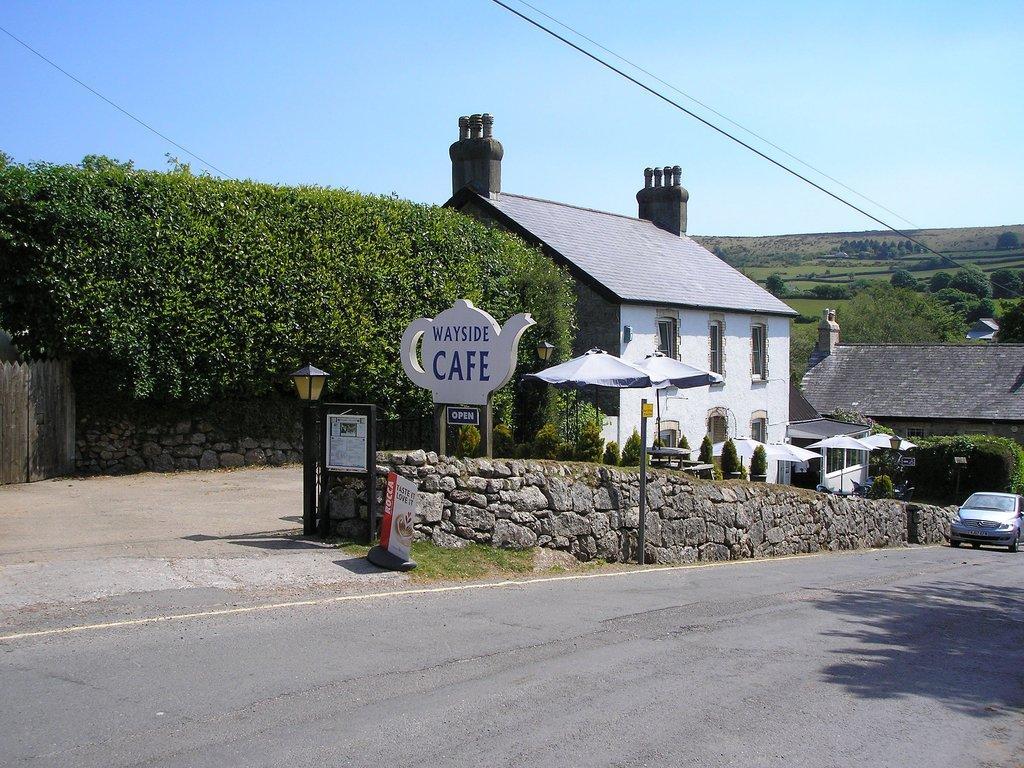Describe this image in one or two sentences. This is an outside view. On the right side there is a car on the road. Beside the road there is a wall and few poles. In the background there are few buildings and trees. On the left side there is a plant on the wall. In the middle of the image there are two umbrellas. At the top of the image I can see the sky and also there are some wires. 